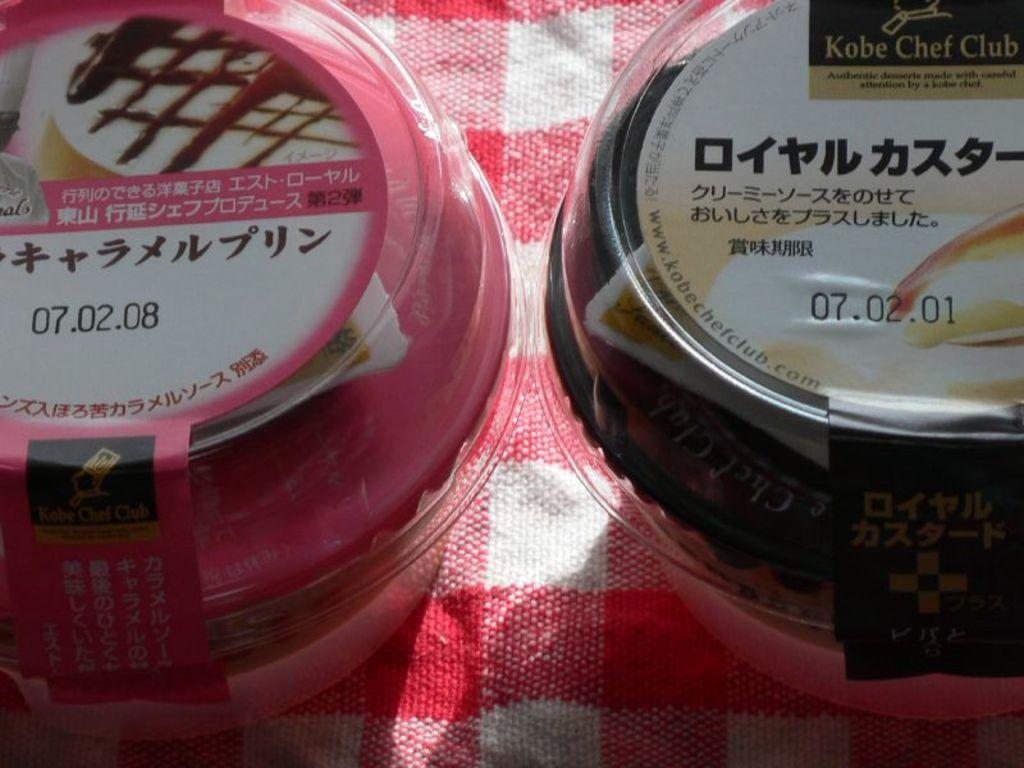<image>
Relay a brief, clear account of the picture shown. Two small containers with white lids and some Chinese writing on them with a date 07.02.08 and 07.02.01 